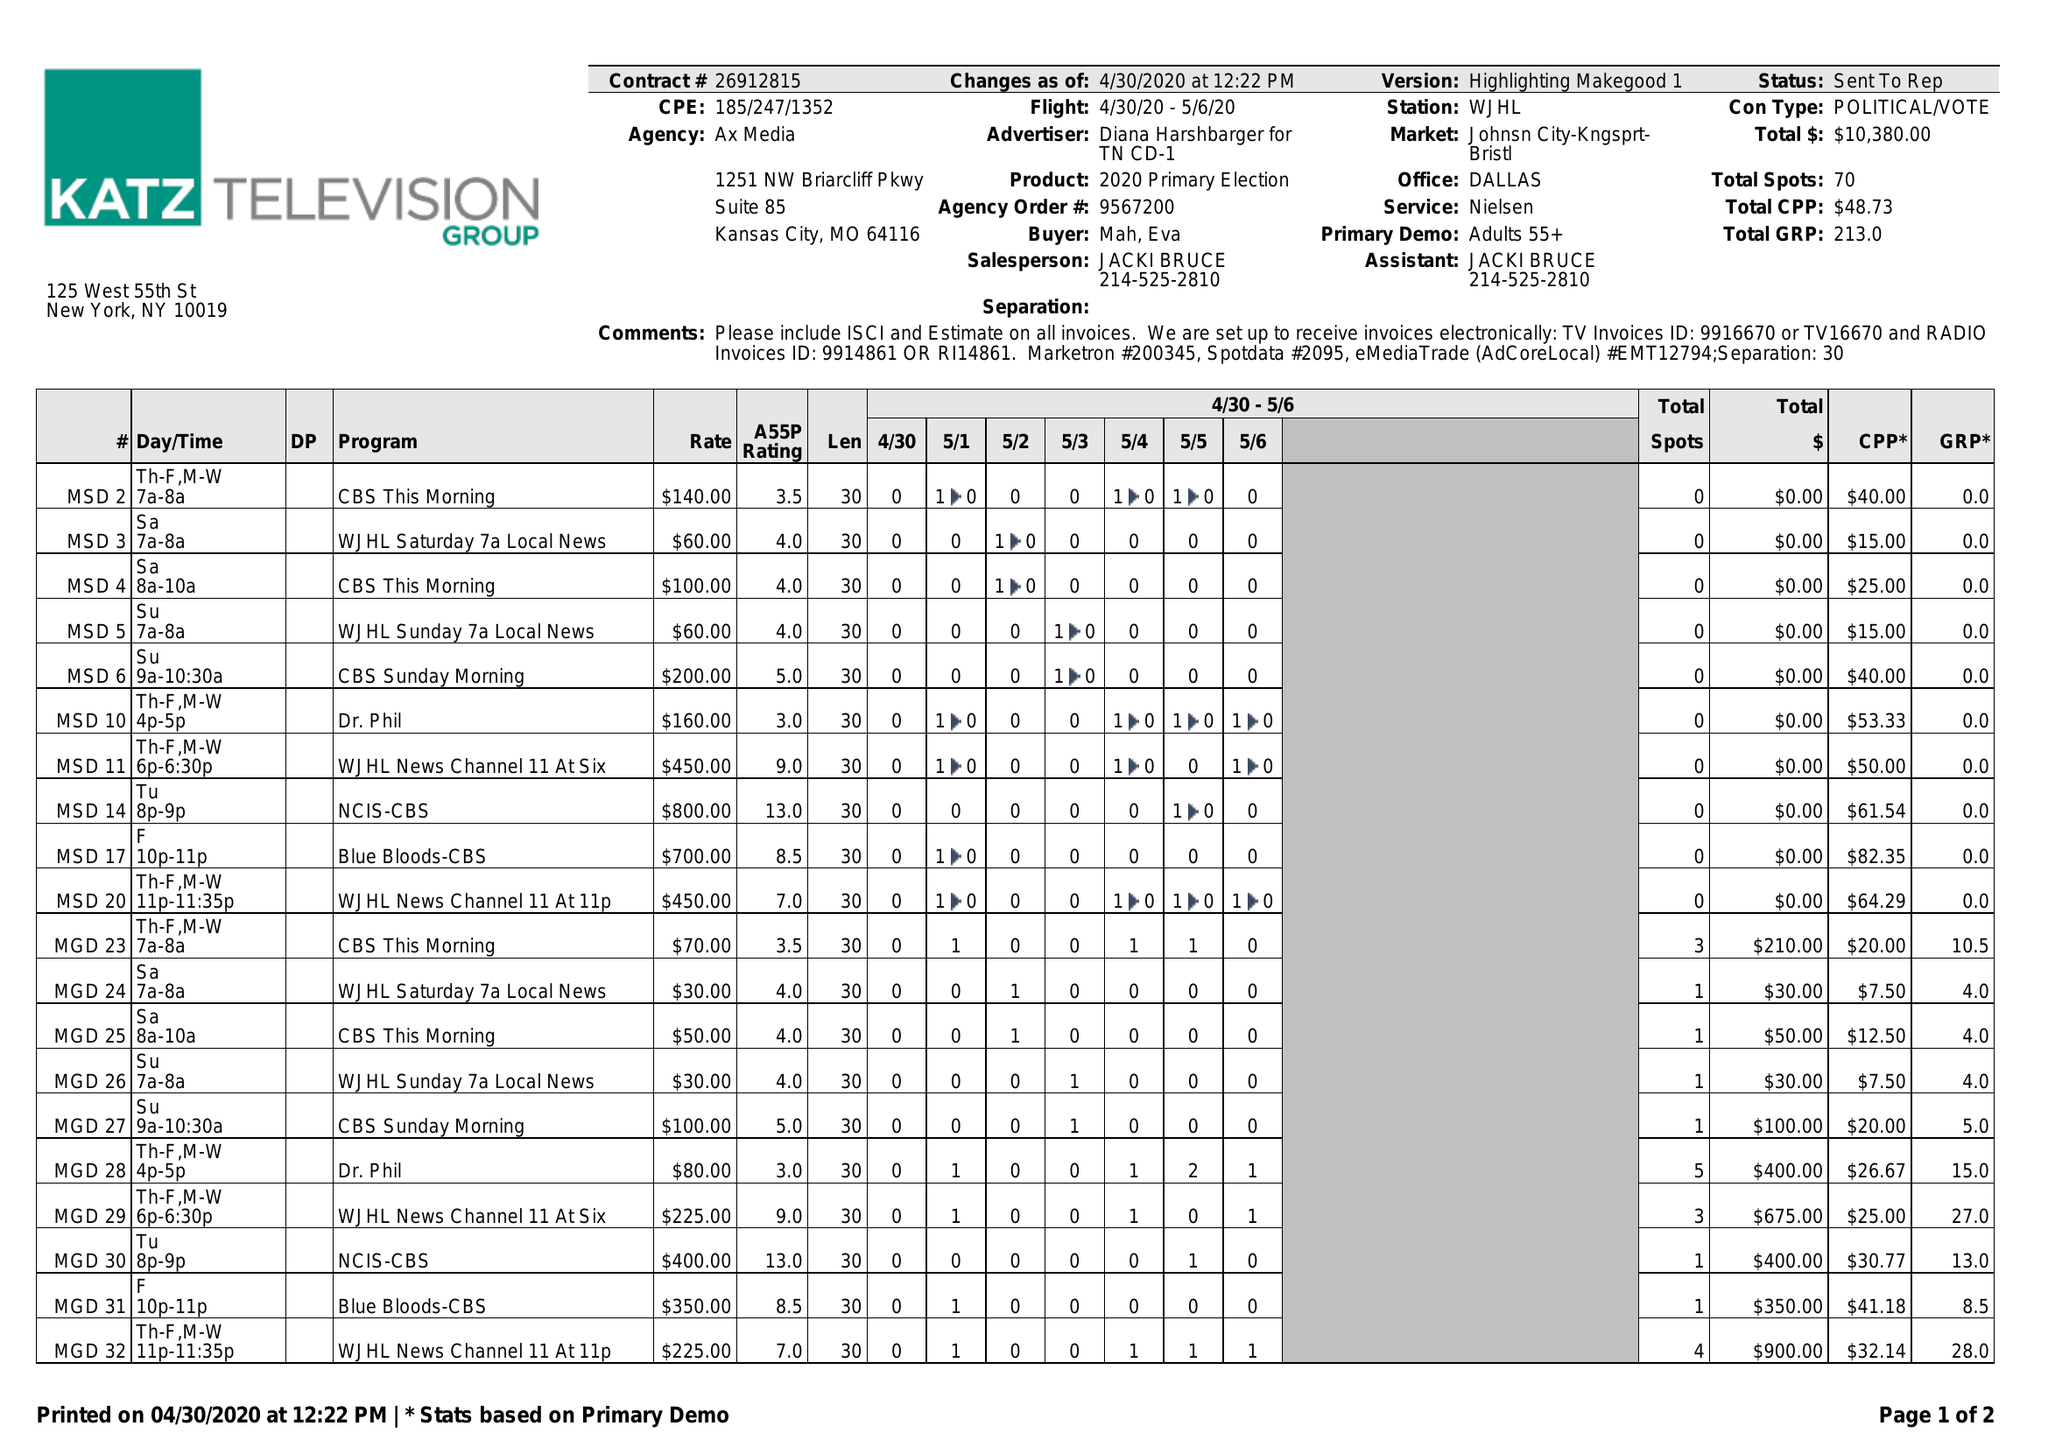What is the value for the gross_amount?
Answer the question using a single word or phrase. 10380.00 